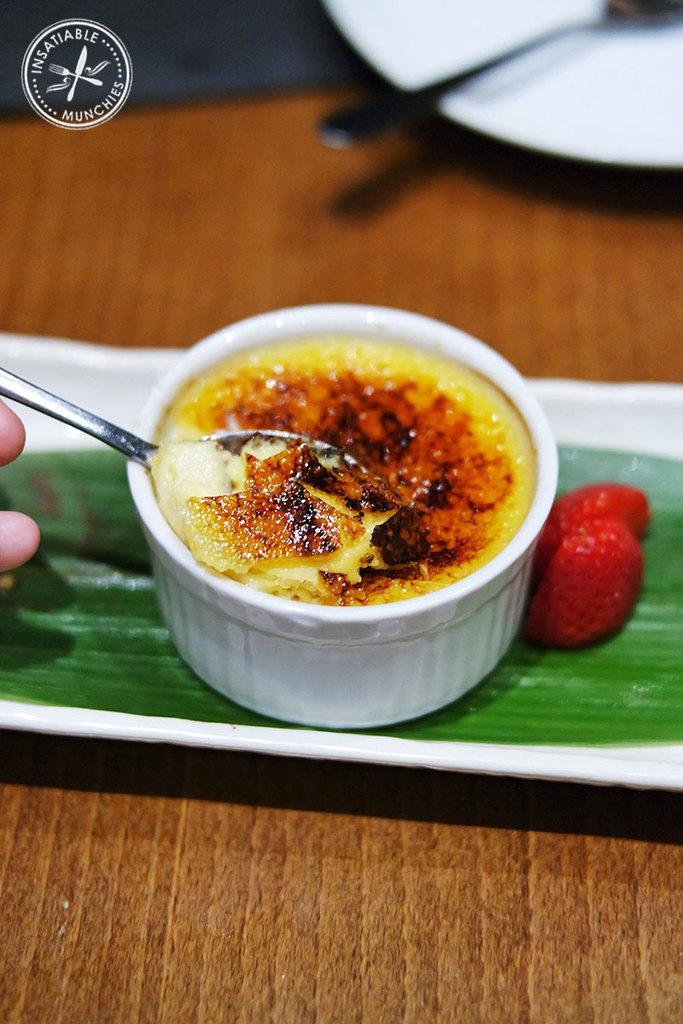Can you describe this image briefly? In this picture we can see a tray, plate on a wooden platform, here we can see a bowl, spoons, food, leaf and a person's fingers, in the top left we can see a logo on it. 